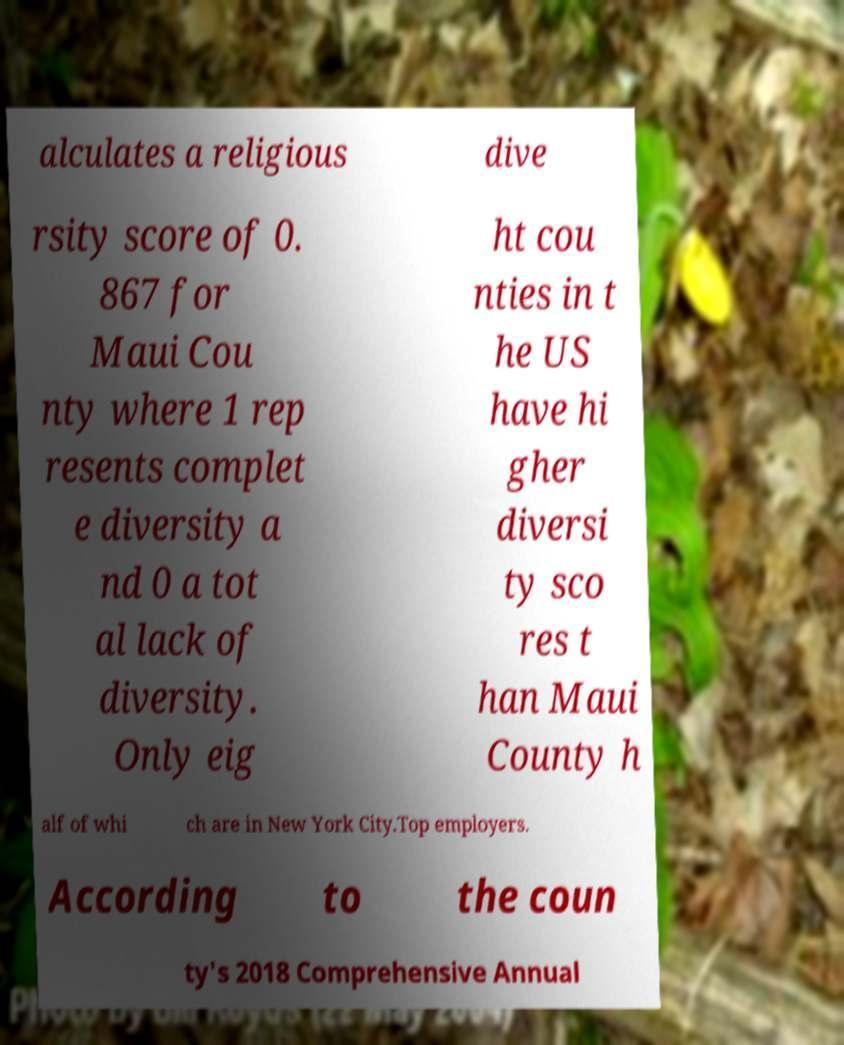Could you extract and type out the text from this image? alculates a religious dive rsity score of 0. 867 for Maui Cou nty where 1 rep resents complet e diversity a nd 0 a tot al lack of diversity. Only eig ht cou nties in t he US have hi gher diversi ty sco res t han Maui County h alf of whi ch are in New York City.Top employers. According to the coun ty's 2018 Comprehensive Annual 